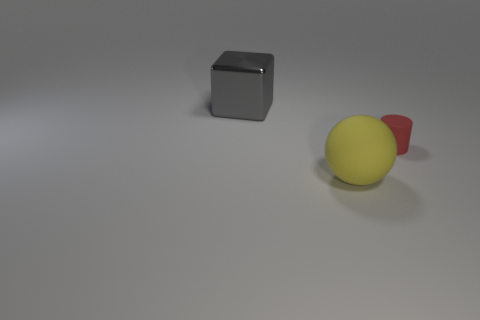Add 3 large yellow rubber blocks. How many objects exist? 6 Subtract all cylinders. How many objects are left? 2 Subtract 1 red cylinders. How many objects are left? 2 Subtract all big blocks. Subtract all yellow balls. How many objects are left? 1 Add 2 gray metal cubes. How many gray metal cubes are left? 3 Add 2 metal blocks. How many metal blocks exist? 3 